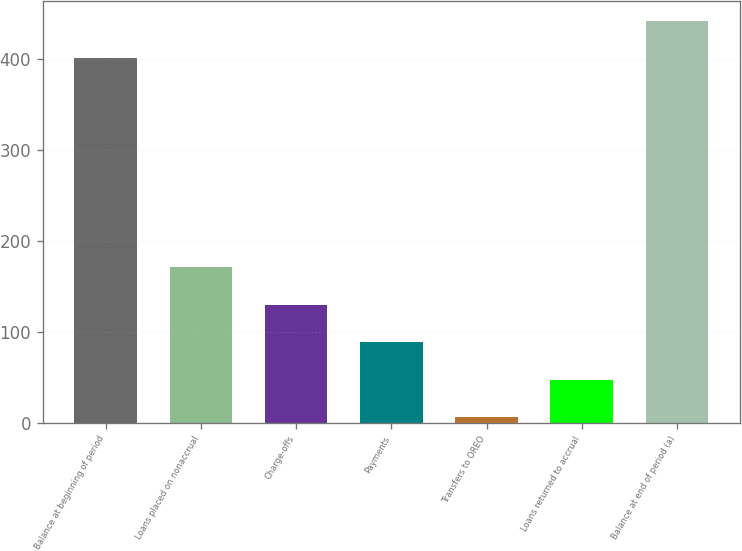Convert chart. <chart><loc_0><loc_0><loc_500><loc_500><bar_chart><fcel>Balance at beginning of period<fcel>Loans placed on nonaccrual<fcel>Charge-offs<fcel>Payments<fcel>Transfers to OREO<fcel>Loans returned to accrual<fcel>Balance at end of period (a)<nl><fcel>401<fcel>170.8<fcel>129.6<fcel>88.4<fcel>6<fcel>47.2<fcel>442.2<nl></chart> 